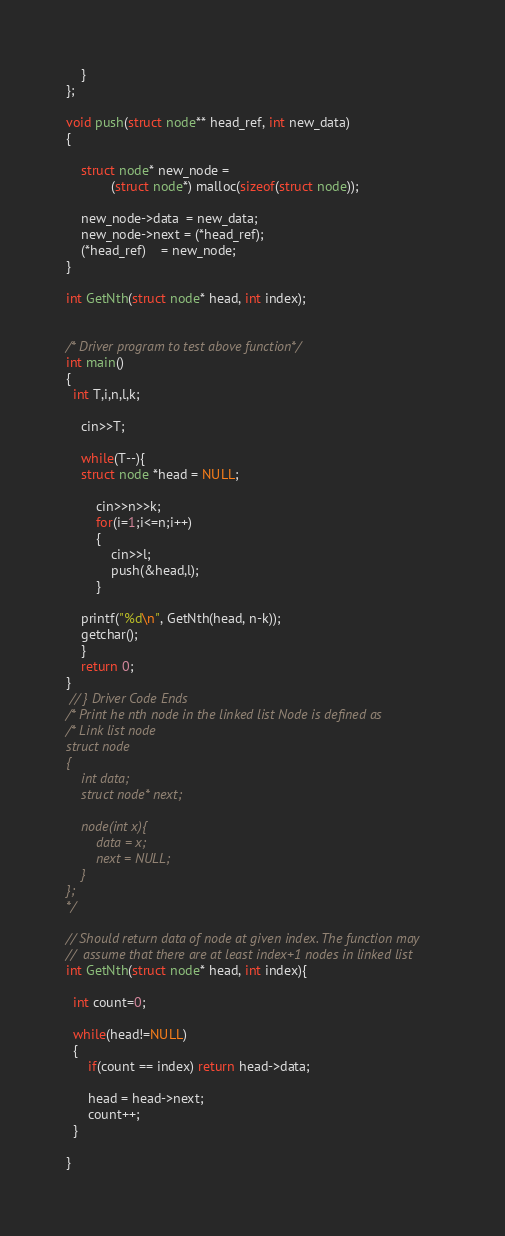<code> <loc_0><loc_0><loc_500><loc_500><_C++_>    }
};
 
void push(struct node** head_ref, int new_data)
{
   
    struct node* new_node =
            (struct node*) malloc(sizeof(struct node));
 
    new_node->data  = new_data;
    new_node->next = (*head_ref);
    (*head_ref)    = new_node;
}

int GetNth(struct node* head, int index);


/* Driver program to test above function*/
int main()
{
  int T,i,n,l,k;
    
    cin>>T;
    
    while(T--){
    struct node *head = NULL;
        
        cin>>n>>k;
        for(i=1;i<=n;i++)
        {
            cin>>l;
            push(&head,l);
        }
   
    printf("%d\n", GetNth(head, n-k));  
    getchar();
    }
    return 0;
}
 // } Driver Code Ends
/* Print he nth node in the linked list Node is defined as 
/* Link list node
struct node
{
    int data;
    struct node* next;
    
    node(int x){
        data = x;
        next = NULL;
    }
}; 
*/

// Should return data of node at given index. The function may
//  assume that there are at least index+1 nodes in linked list
int GetNth(struct node* head, int index){
  
  int count=0;
  
  while(head!=NULL)
  {
      if(count == index) return head->data;
      
      head = head->next;
      count++;
  }
  
}
</code> 